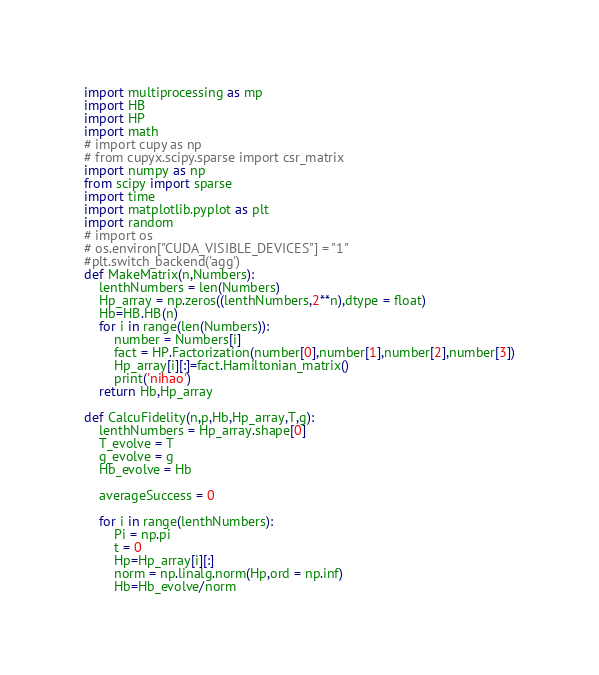Convert code to text. <code><loc_0><loc_0><loc_500><loc_500><_Python_>import multiprocessing as mp
import HB 
import HP
import math
# import cupy as np  
# from cupyx.scipy.sparse import csr_matrix
import numpy as np
from scipy import sparse
import time
import matplotlib.pyplot as plt
import random
# import os
# os.environ["CUDA_VISIBLE_DEVICES"] = "1"
#plt.switch_backend('agg')
def MakeMatrix(n,Numbers):
	lenthNumbers = len(Numbers)
	Hp_array = np.zeros((lenthNumbers,2**n),dtype = float)
	Hb=HB.HB(n)
	for i in range(len(Numbers)):
		number = Numbers[i]
		fact = HP.Factorization(number[0],number[1],number[2],number[3])
		Hp_array[i][:]=fact.Hamiltonian_matrix()
		print('nihao')
	return Hb,Hp_array

def CalcuFidelity(n,p,Hb,Hp_array,T,g):
	lenthNumbers = Hp_array.shape[0]
	T_evolve = T
	g_evolve = g
	Hb_evolve = Hb

	averageSuccess = 0

	for i in range(lenthNumbers):
		Pi = np.pi
		t = 0   
		Hp=Hp_array[i][:]
		norm = np.linalg.norm(Hp,ord = np.inf)
		Hb=Hb_evolve/norm</code> 